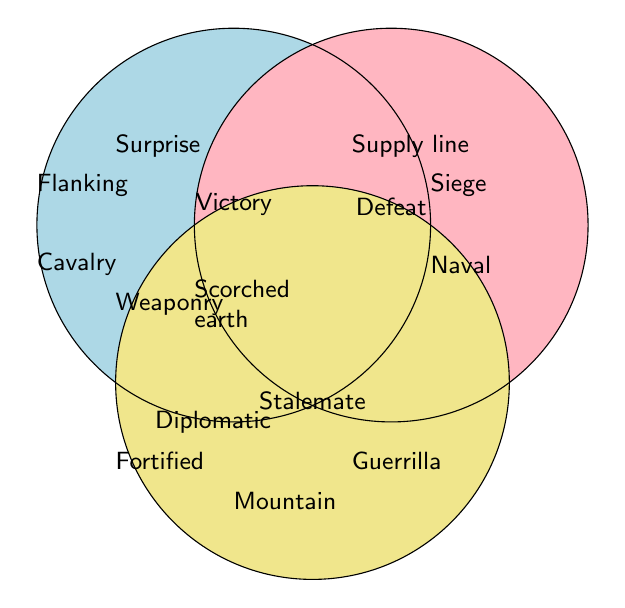What types of strategies are listed under Victory? By looking at the section labeled "Victory" in the Venn diagram, we can see the strategies listed in that circle: Flanking maneuvers, Cavalry charges, Surprise attacks, Scorched earth tactics, and Superior weaponry
Answer: Flanking maneuvers, Cavalry charges, Surprise attacks, Scorched earth tactics, Superior weaponry Which strategy type is common between Defeat and Stalemate? By identifying the strategies listed in the overlapping area between Defeat and Stalemate circles, we notice that Guerrilla tactics is the common strategy
Answer: Guerrilla tactics How many total strategies are listed in the Venn Diagram? Count all the strategies in each separate section: 5 in Victory, 3 in Defeat, 4 in Stalemate. Then sum them: 5 + 3 + 4 = 12
Answer: 12 Which strategy is unique to Victory and does not overlap with Defeat or Stalemate? By looking at the Victory section and ensuring it doesn’t fall in any overlapped area, the unique strategy is Superior weaponry
Answer: Superior weaponry What color represents Defeat in the diagram? Observing the color coding, Defeat is represented by a pinkish color in the diagram
Answer: Pink Which strategy in the Stalemate section involves avoiding direct confrontation? The strategy with this characteristic is "Diplomatic negotiations," found in the Stalemate section
Answer: Diplomatic negotiations How many strategies are shared between Victory and Defeat but not Stalemate? Checking the overlapping area between Victory and Defeat, there are no strategies listed that fall into just these two categories without Stalemate as well
Answer: 0 What are the strategies related to Naval battles? By finding the location of Naval battles, it is solely within the Defeat circle
Answer: Defeat Which section has the most number of unique strategies? By counting strategies per section: Victory has 5, Defeat has 3, Stalemate has 4. Victory has the most unique strategies
Answer: Victory 